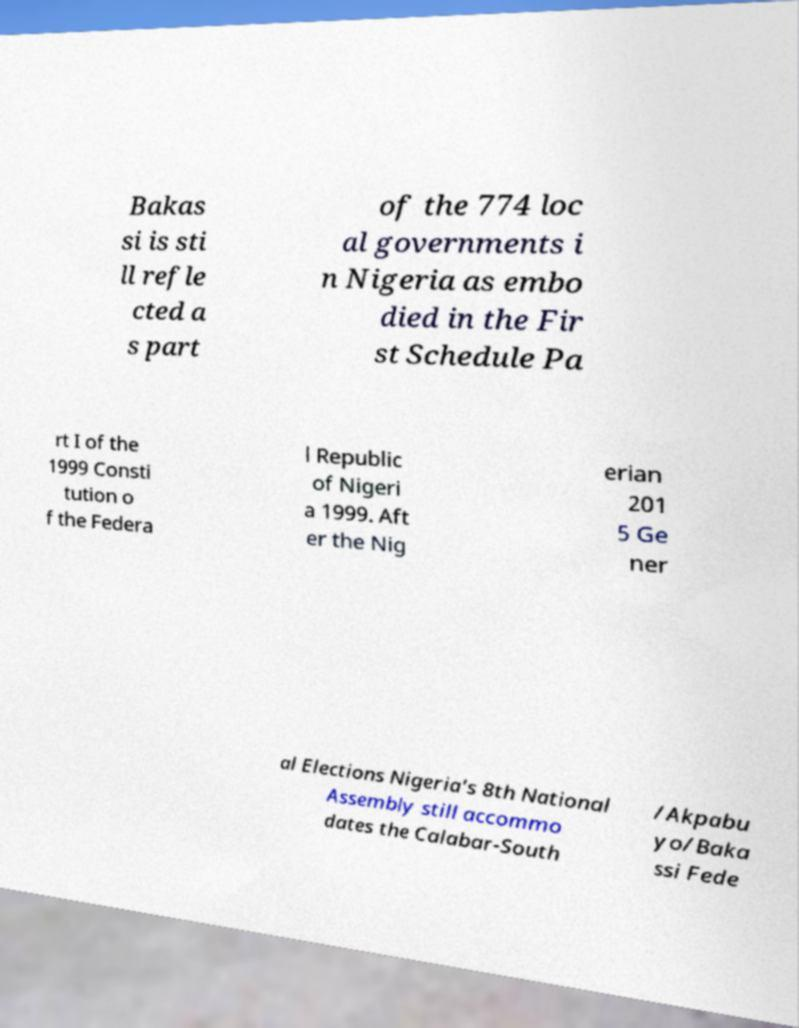Please read and relay the text visible in this image. What does it say? Bakas si is sti ll refle cted a s part of the 774 loc al governments i n Nigeria as embo died in the Fir st Schedule Pa rt I of the 1999 Consti tution o f the Federa l Republic of Nigeri a 1999. Aft er the Nig erian 201 5 Ge ner al Elections Nigeria's 8th National Assembly still accommo dates the Calabar-South /Akpabu yo/Baka ssi Fede 